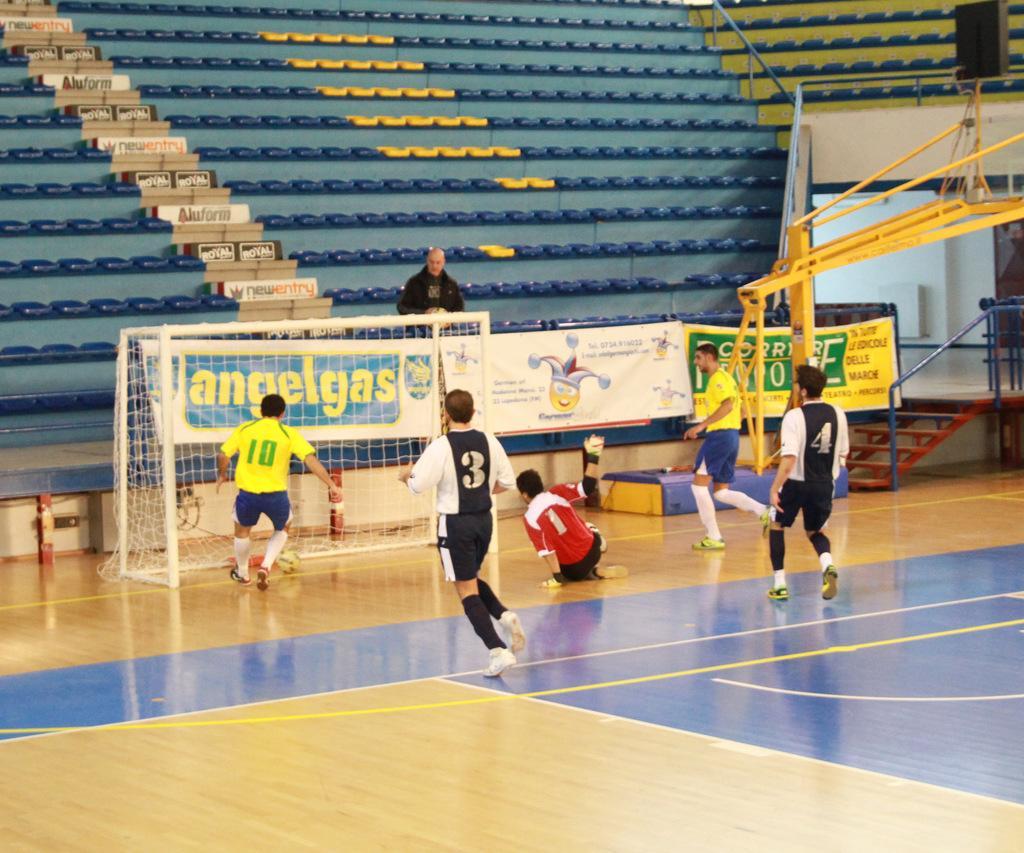How would you summarize this image in a sentence or two? This image is taken indoors. At the bottom of the image there is a floor. In the background there are many seats and there are a few stairs. There are many boards with text on them. A man is sitting on the seat. There is a railing. In the middle of the image a few boys are playing football. There is a goal court and there is a ball. On the right side of the image there are a few stairs and there is a railing. There is an object. 